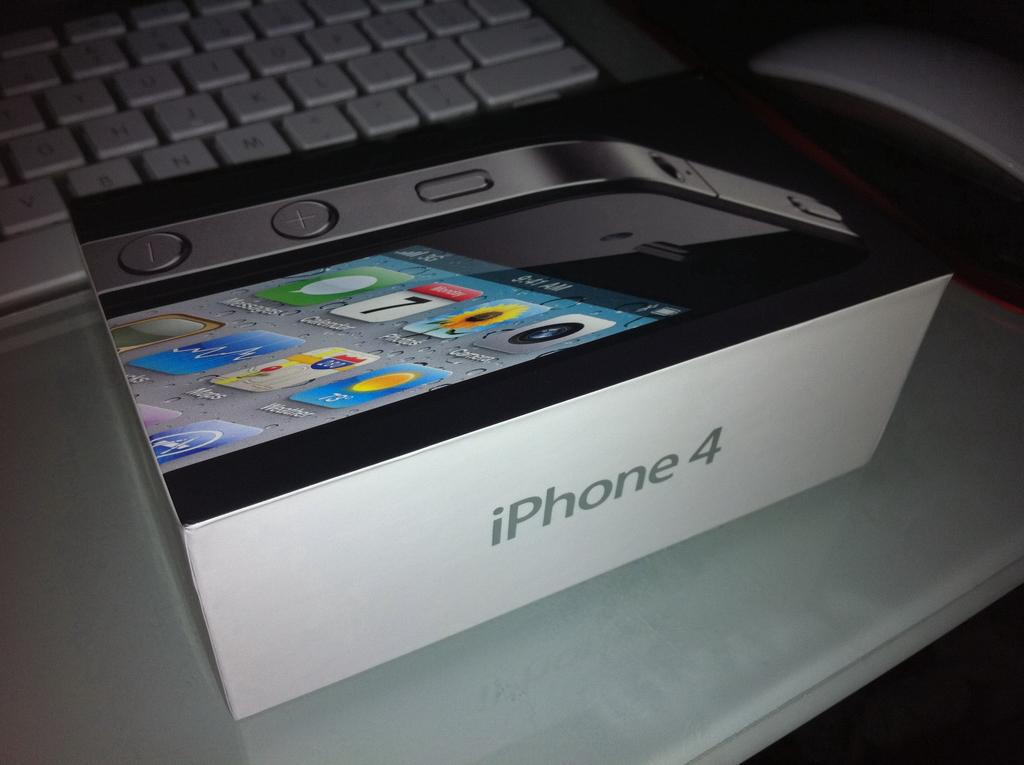<image>
Summarize the visual content of the image. a case that is for an iPhone 4 